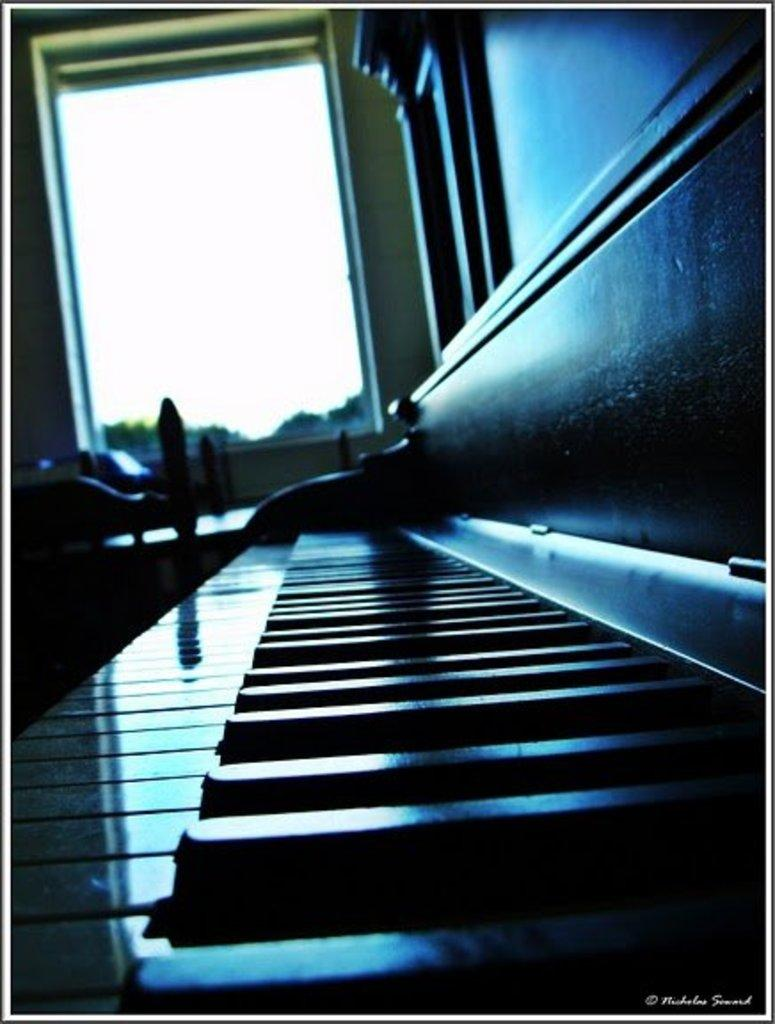What is the main object in the image? There is a keyboard in the image. What can be seen in the background of the image? There is a wall and a glass window in the background of the image. What type of credit can be seen on the keyboard in the image? There is no credit visible on the keyboard in the image. What message does the son write on the letter in the image? There is no son or letter present in the image. 